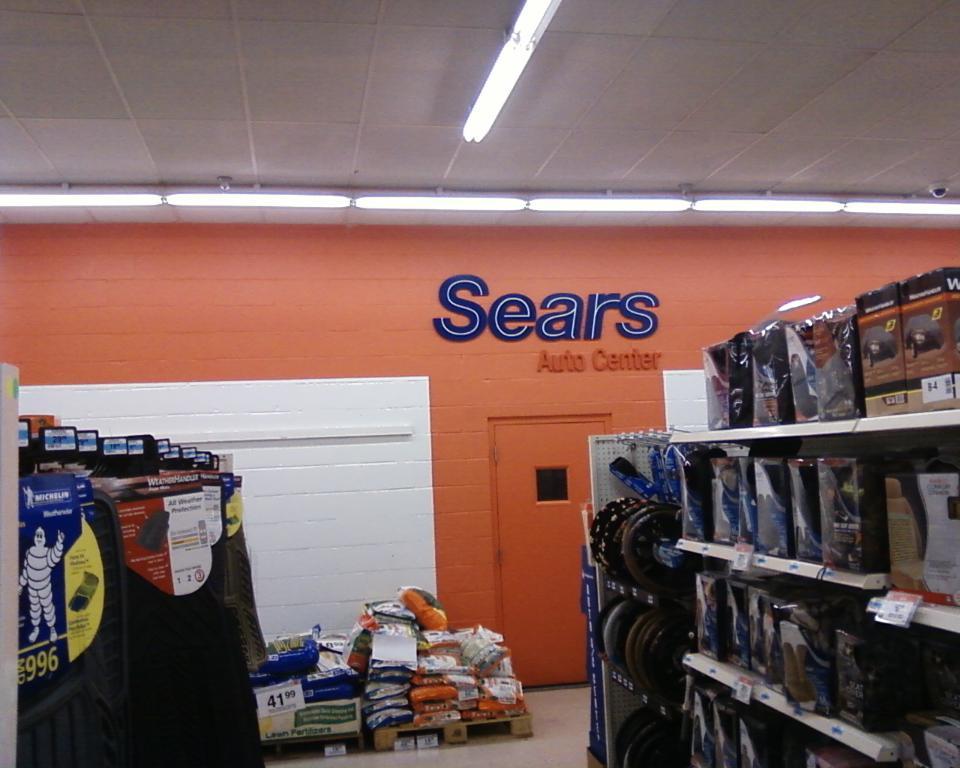What store is this?
Your answer should be compact. Sears. The store is sears?
Offer a very short reply. Yes. 